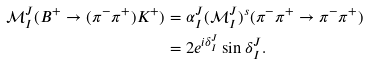Convert formula to latex. <formula><loc_0><loc_0><loc_500><loc_500>\mathcal { M } ^ { J } _ { I } ( B ^ { + } \to ( \pi ^ { - } \pi ^ { + } ) K ^ { + } ) & = \alpha ^ { J } _ { I } ( \mathcal { M } ^ { J } _ { I } ) ^ { s } ( \pi ^ { - } \pi ^ { + } \to \pi ^ { - } \pi ^ { + } ) \\ & = 2 e ^ { i \delta ^ { J } _ { I } } \sin \delta ^ { J } _ { I } .</formula> 